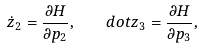Convert formula to latex. <formula><loc_0><loc_0><loc_500><loc_500>\dot { z } _ { 2 } = \frac { \partial H } { \partial p _ { 2 } } , \quad d o t z _ { 3 } = \frac { \partial H } { \partial p _ { 3 } } ,</formula> 